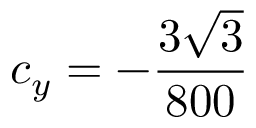Convert formula to latex. <formula><loc_0><loc_0><loc_500><loc_500>c _ { y } = - \frac { 3 \sqrt { 3 } } { 8 0 0 }</formula> 